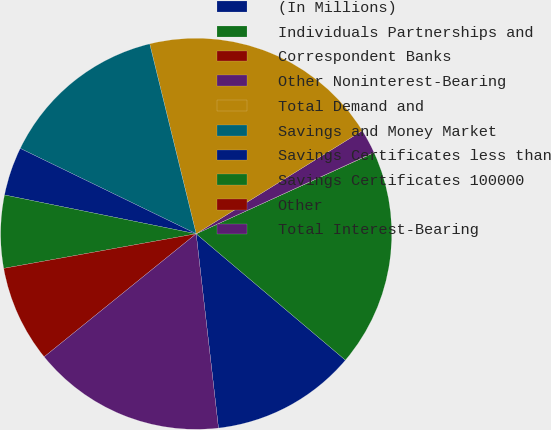Convert chart to OTSL. <chart><loc_0><loc_0><loc_500><loc_500><pie_chart><fcel>(In Millions)<fcel>Individuals Partnerships and<fcel>Correspondent Banks<fcel>Other Noninterest-Bearing<fcel>Total Demand and<fcel>Savings and Money Market<fcel>Savings Certificates less than<fcel>Savings Certificates 100000<fcel>Other<fcel>Total Interest-Bearing<nl><fcel>12.0%<fcel>17.99%<fcel>0.02%<fcel>2.01%<fcel>19.98%<fcel>13.99%<fcel>4.01%<fcel>6.01%<fcel>8.0%<fcel>15.99%<nl></chart> 